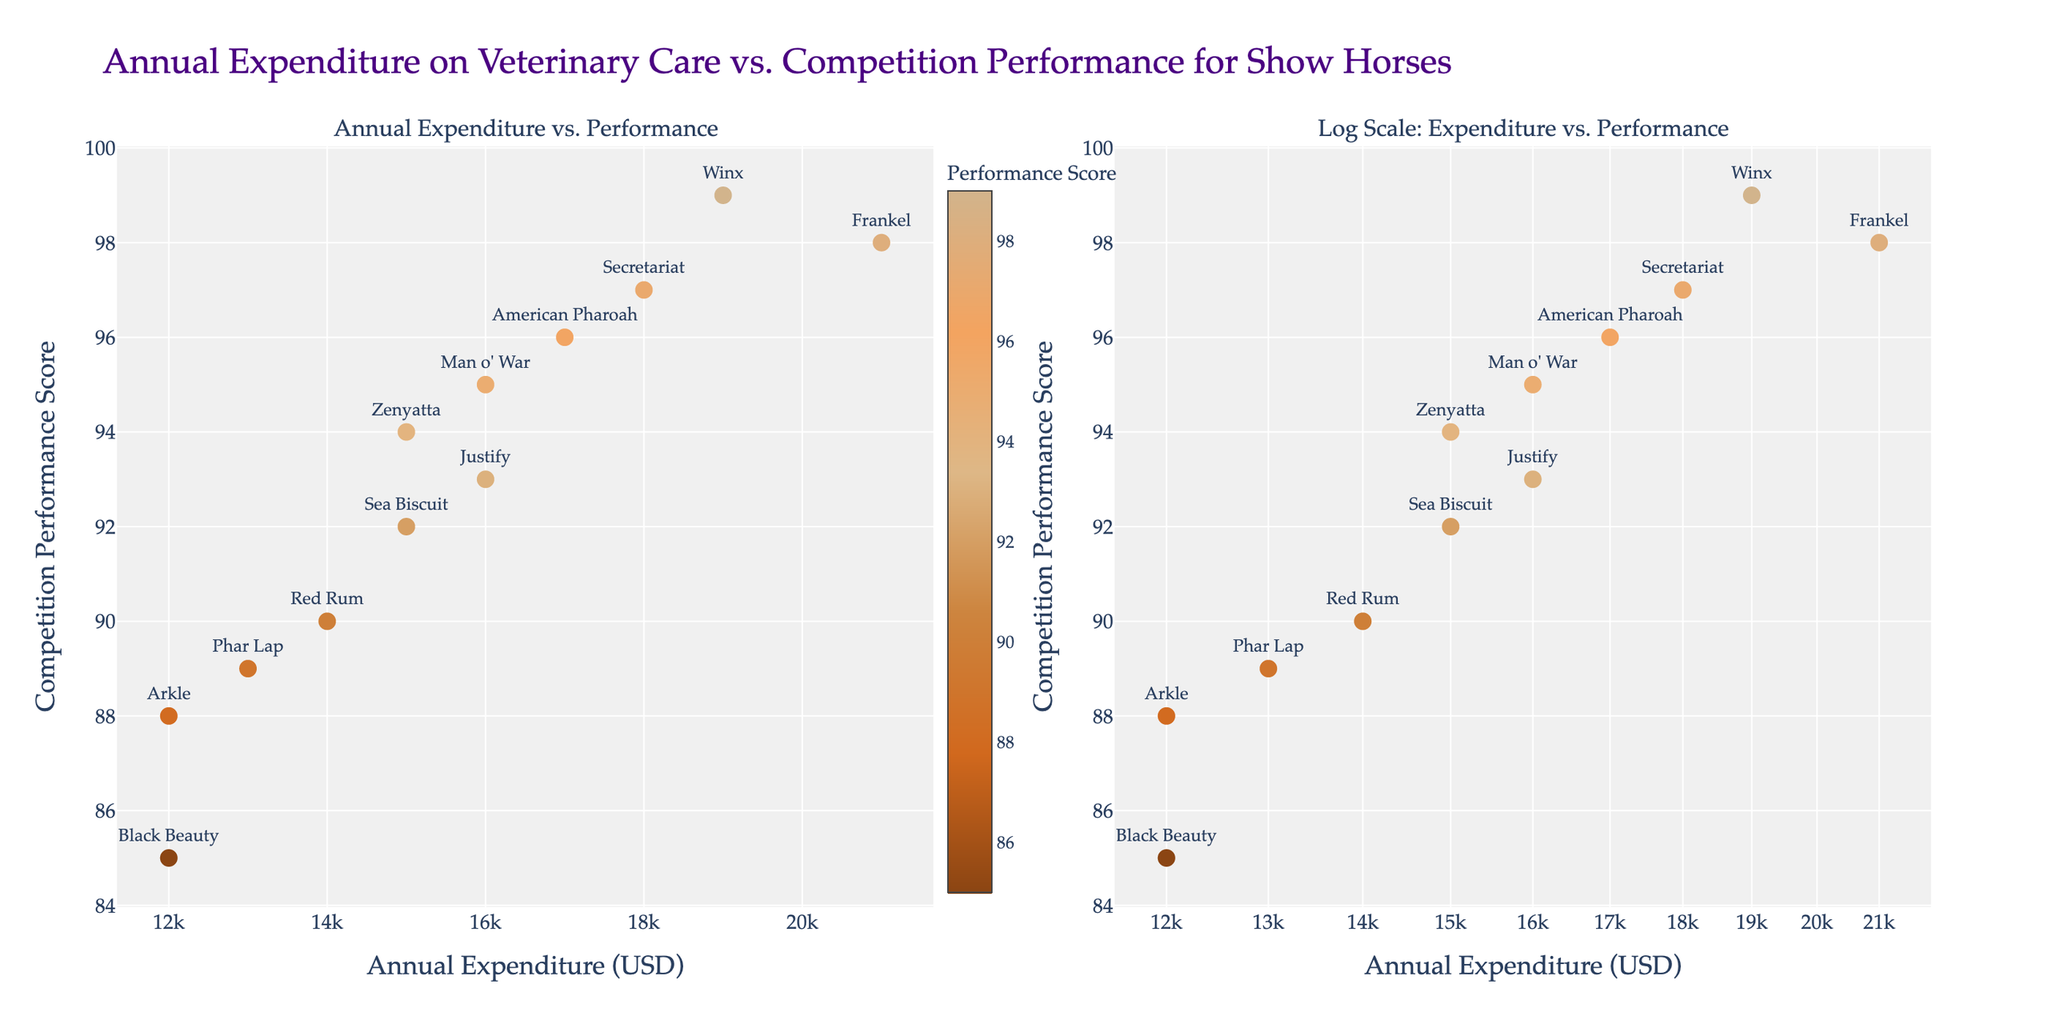How many horses have an annual veterinary expenditure above $15,000? Look at the x-axis of both subplots to locate the points representing expenditures above $15,000. Count the number of these points.
Answer: 7 Which horse has the highest competition performance score? Look at the y-axis of both subplots. Identify the point that reaches the highest score and check the associated label.
Answer: Winx Is there a horse with an annual expenditure of $12,000? If yes, what are their performance scores? Identify points on the x-axis in the linear scale subplot with an expenditure of $12,000, then look at their corresponding y-axis values and labels.
Answer: Black Beauty (85), Arkle (88) Which horse shows the highest competition performance score for an annual expenditure under $16,000? On the linear scale subplot, look at points with an expenditure below $16,000. Compare their performance scores and identify the highest one.
Answer: Justify (93) How does the marker color correlate with competition performance scores? Observe the subplot: marker color indicates performance scores with a colorscale. As scores increase, colors tend to brighten or change hue.
Answer: Colors indicate performance What can be inferred about the distribution of data points on the log scale axis compared to the linear scale? Compare the spread and clustering of points in both subplots. The log scale subplot will show a different distribution emphasizing lower expenditures.
Answer: Log scale emphasizes lower expenditures What is the most frequent annual expenditure value among the horses? Identify the data points on the x-axis in the linear scale subplot and check for recurring expenditure values.
Answer: $15,000 and $16,000 Do all horses with an expenditure above $17,000 also score above 95 in performance? Check points on the x-axis in both subplots where expenditures are above $17,000. Then, compare their y-axis values.
Answer: No 